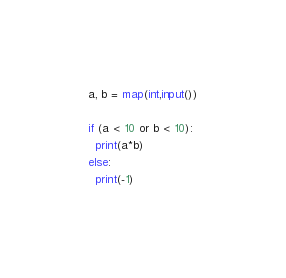Convert code to text. <code><loc_0><loc_0><loc_500><loc_500><_Python_>a, b = map(int,input())

if (a < 10 or b < 10):
  print(a*b)
else:
  print(-1)</code> 